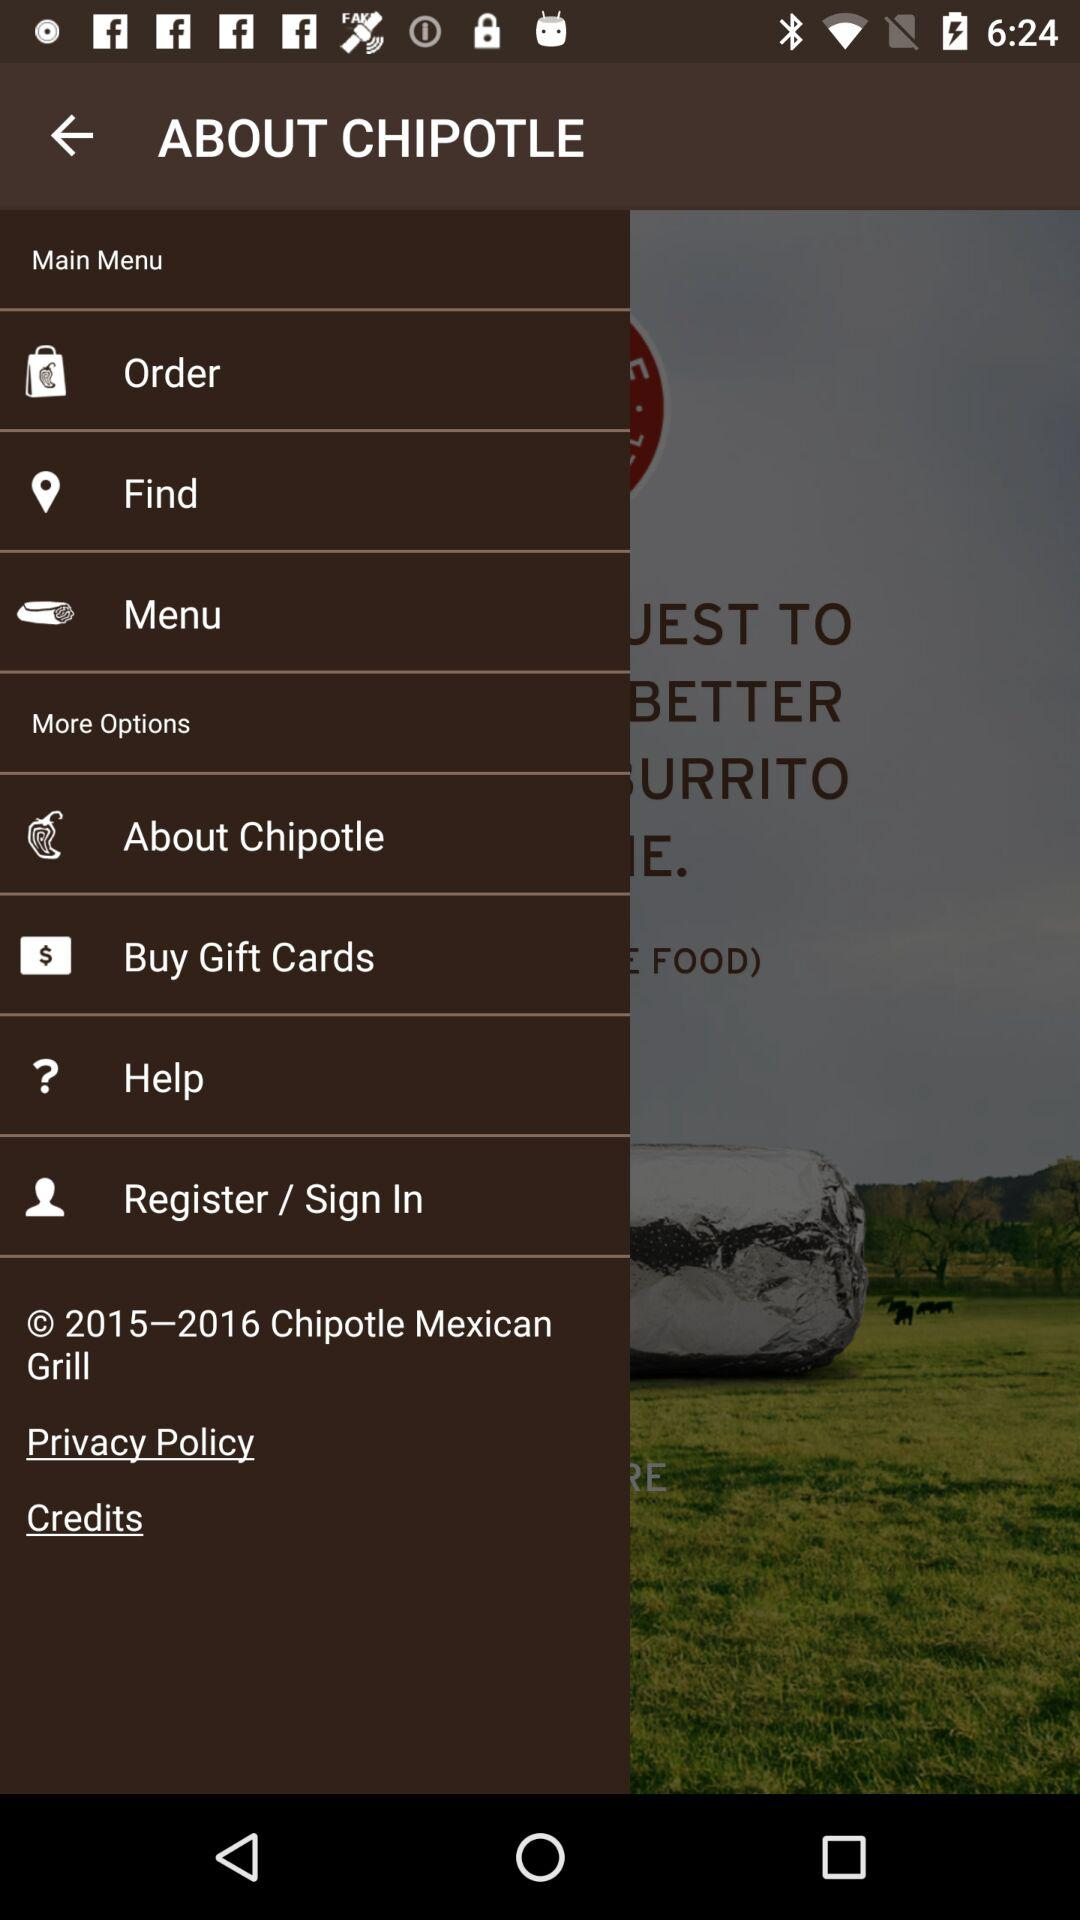What is the name of the application? The name of the application is "CHIPOTLE". 